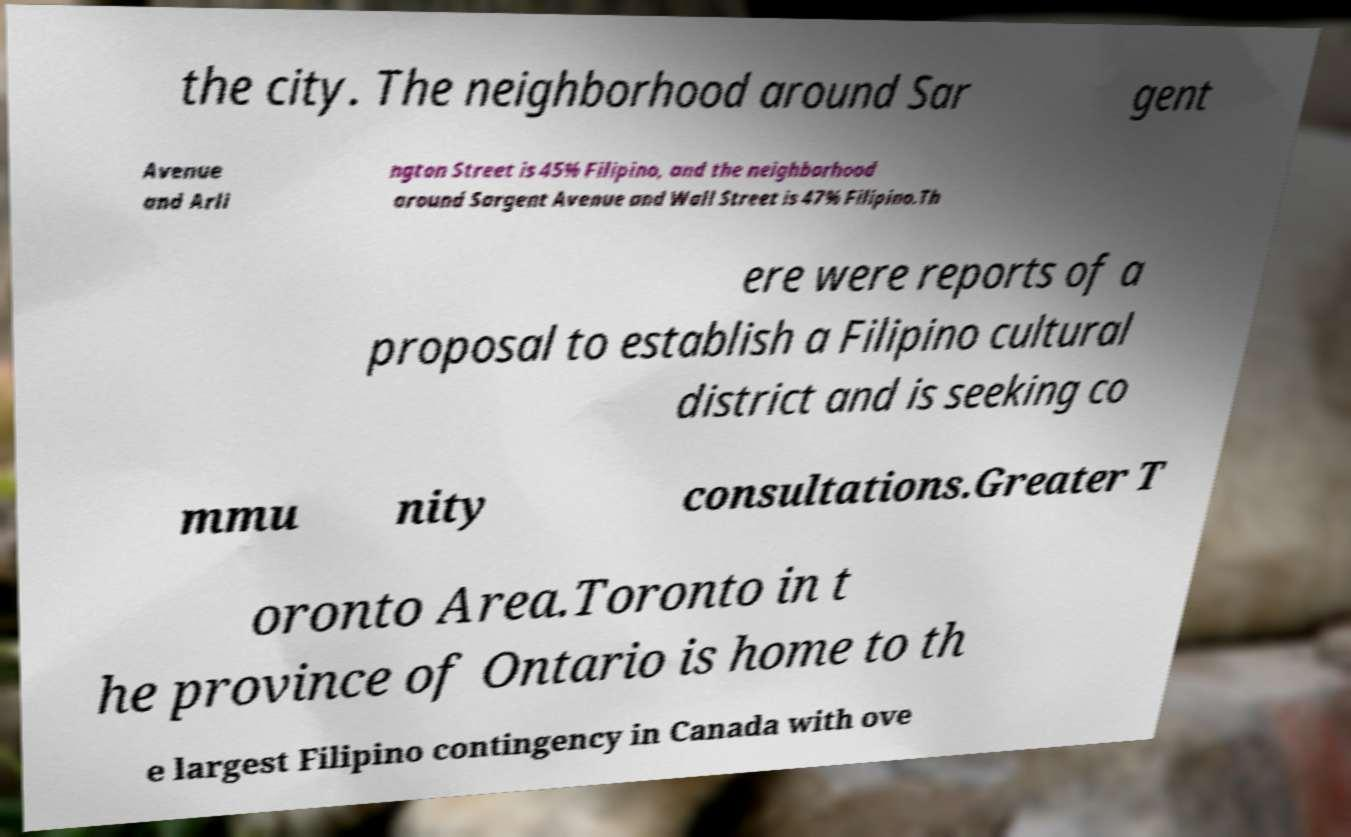Could you extract and type out the text from this image? the city. The neighborhood around Sar gent Avenue and Arli ngton Street is 45% Filipino, and the neighborhood around Sargent Avenue and Wall Street is 47% Filipino.Th ere were reports of a proposal to establish a Filipino cultural district and is seeking co mmu nity consultations.Greater T oronto Area.Toronto in t he province of Ontario is home to th e largest Filipino contingency in Canada with ove 